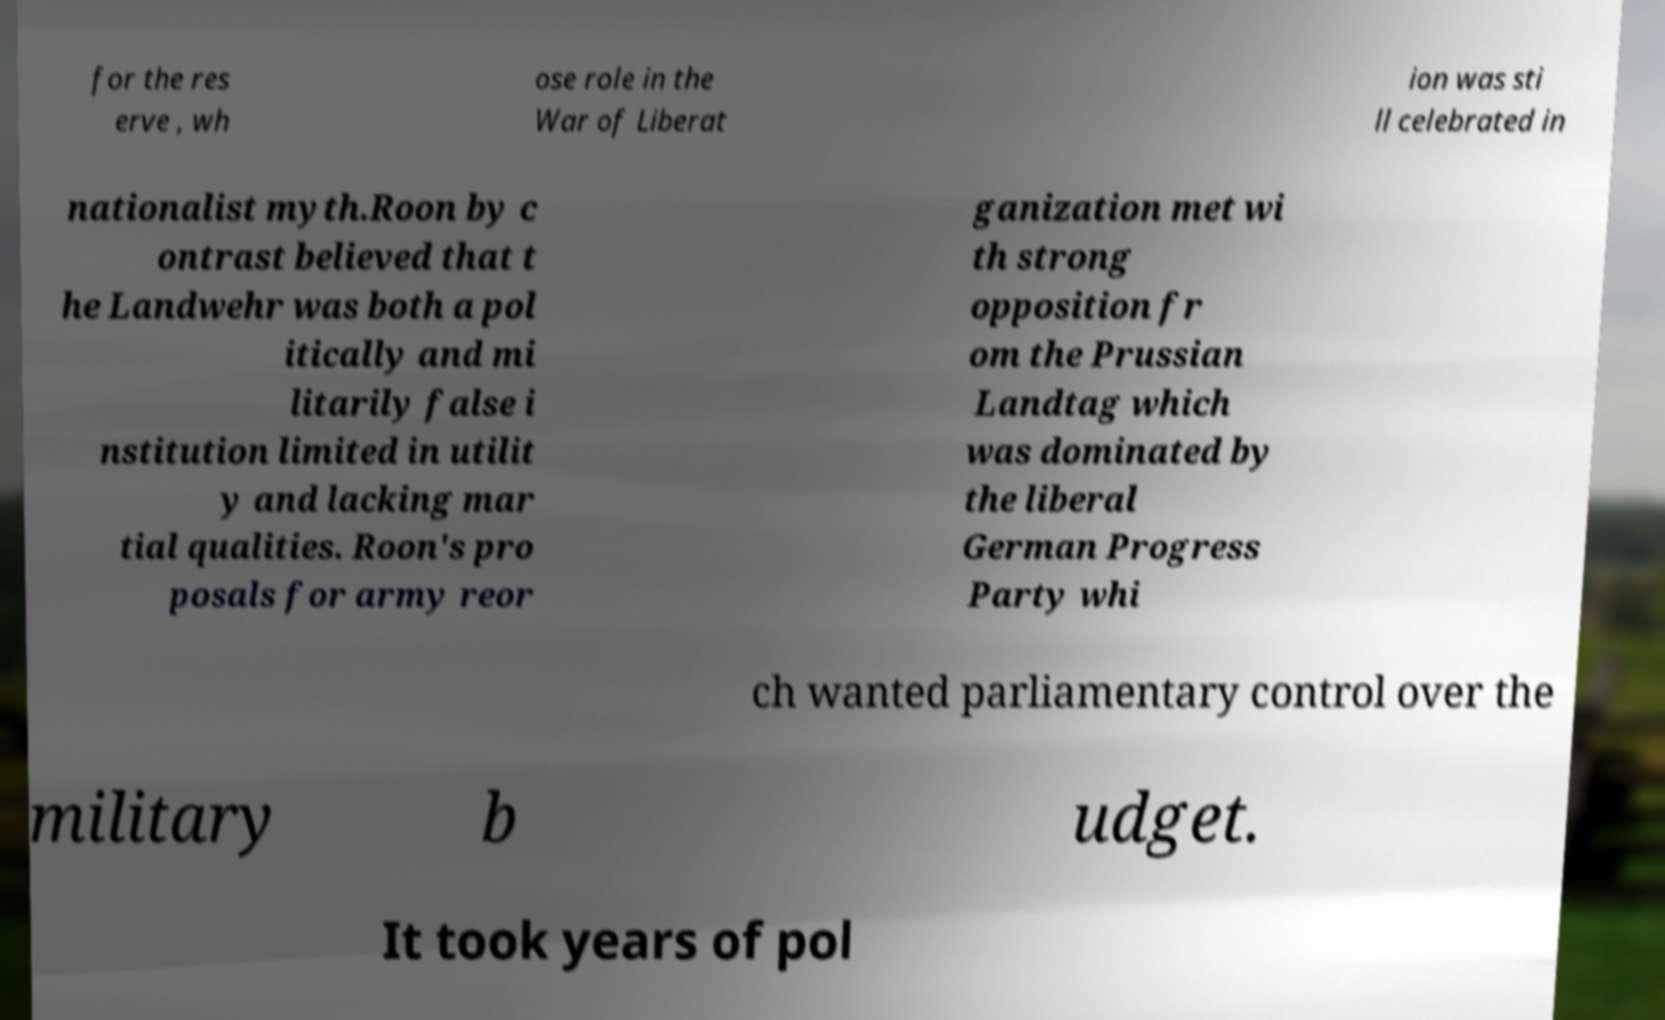There's text embedded in this image that I need extracted. Can you transcribe it verbatim? for the res erve , wh ose role in the War of Liberat ion was sti ll celebrated in nationalist myth.Roon by c ontrast believed that t he Landwehr was both a pol itically and mi litarily false i nstitution limited in utilit y and lacking mar tial qualities. Roon's pro posals for army reor ganization met wi th strong opposition fr om the Prussian Landtag which was dominated by the liberal German Progress Party whi ch wanted parliamentary control over the military b udget. It took years of pol 